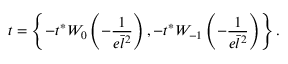Convert formula to latex. <formula><loc_0><loc_0><loc_500><loc_500>t = \left \{ - t ^ { * } W _ { 0 } \left ( - \frac { 1 } { e \bar { l } ^ { 2 } } \right ) , - t ^ { * } W _ { - 1 } \left ( - \frac { 1 } { e \bar { l } ^ { 2 } } \right ) \right \} .</formula> 